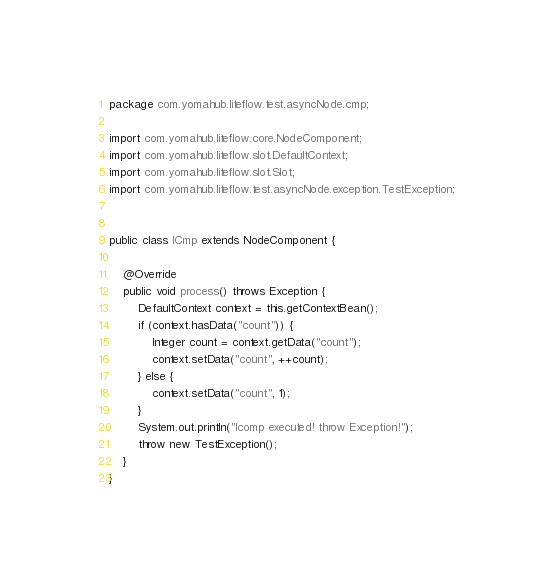Convert code to text. <code><loc_0><loc_0><loc_500><loc_500><_Java_>package com.yomahub.liteflow.test.asyncNode.cmp;

import com.yomahub.liteflow.core.NodeComponent;
import com.yomahub.liteflow.slot.DefaultContext;
import com.yomahub.liteflow.slot.Slot;
import com.yomahub.liteflow.test.asyncNode.exception.TestException;


public class ICmp extends NodeComponent {

    @Override
    public void process() throws Exception {
        DefaultContext context = this.getContextBean();
        if (context.hasData("count")) {
            Integer count = context.getData("count");
            context.setData("count", ++count);
        } else {
            context.setData("count", 1);
        }
        System.out.println("Icomp executed! throw Exception!");
        throw new TestException();
    }
}</code> 